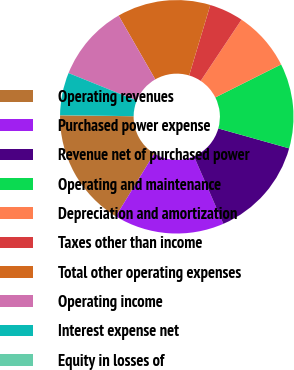<chart> <loc_0><loc_0><loc_500><loc_500><pie_chart><fcel>Operating revenues<fcel>Purchased power expense<fcel>Revenue net of purchased power<fcel>Operating and maintenance<fcel>Depreciation and amortization<fcel>Taxes other than income<fcel>Total other operating expenses<fcel>Operating income<fcel>Interest expense net<fcel>Equity in losses of<nl><fcel>16.46%<fcel>15.28%<fcel>14.11%<fcel>11.76%<fcel>8.24%<fcel>4.72%<fcel>12.94%<fcel>10.59%<fcel>5.89%<fcel>0.02%<nl></chart> 